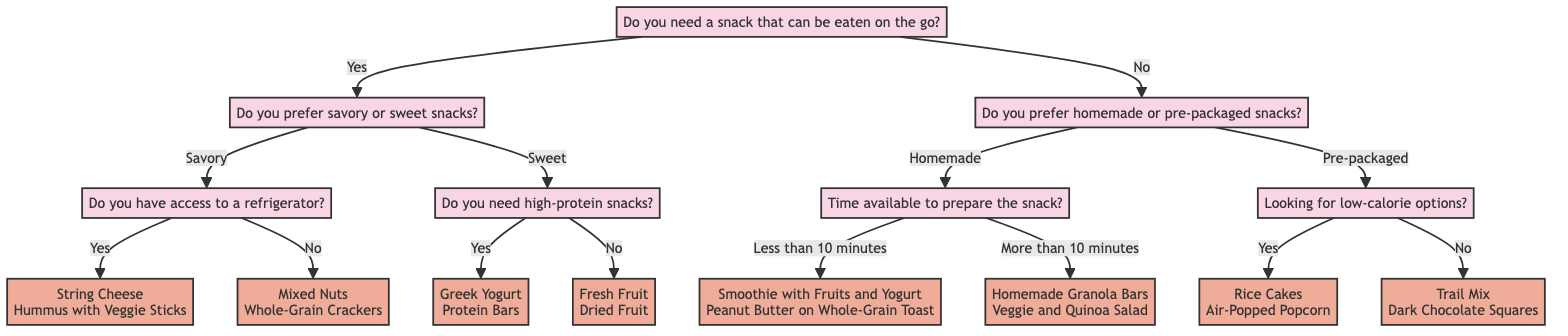What is the first question in the decision tree? The first question in the decision tree is about whether a snack can be eaten on the go. It is posed at the root of the tree and leads to further questions based on the answer.
Answer: Do you need a snack that can be eaten on the go? How many options are available for savory snacks with refrigerator access? When following the path for savory snacks that require a refrigerator, there are two options provided: String Cheese and Hummus with Veggie Sticks. This is derived from the subtree that follows the savory answer under the go question where refrigerator access is affirmed.
Answer: 2 What type of snacks does the tree recommend for someone who prefers homemade snacks and has more than 10 minutes to prepare? Following the path from the decision about preferring homemade snacks, if the user has more than 10 minutes, the options presented are Homemade Granola Bars and Veggie and Quinoa Salad. This follows the logical flow through the diagram to reach these recommendations.
Answer: Homemade Granola Bars, Veggie and Quinoa Salad What snacks are suggested for pre-packaged low-calorie options? If the user prefers pre-packaged snacks and is looking for low-calorie options, they are directed to Rice Cakes and Air-Popped Popcorn. This decision flows through the tree based on the preference for pre-packaged snacks and subsequently seeking lower calorie snacks.
Answer: Rice Cakes, Air-Popped Popcorn If a user answers "No" to having a snack that can be eaten on the go, what is the next question they will encounter? The user who answers "No" to the first question will be asked whether they prefer homemade or pre-packaged snacks. This question follows directly as the next step in the decision-making process in the tree.
Answer: Do you prefer homemade or pre-packaged snacks? What are the two options available if the user prefers sweet snacks and does not need high-protein snacks? If the user prefers sweet snacks and answers that they do not require high-protein, the options presented are Fresh Fruit and Dried Fruit. This is found by tracing the path corresponding to those specific responses in the decision tree.
Answer: Fresh Fruit, Dried Fruit What type of snacks are suggested if the user prefers savory snacks and does not have access to a refrigerator? The path for savory snacks without refrigerator access leads to two options: Mixed Nuts and Whole-Grain Crackers. This is obtained by navigating through the decision tree based on the given answers.
Answer: Mixed Nuts, Whole-Grain Crackers How many types of questions are present in this decision tree? The decision tree contains three types of questions: whether a snack can be eaten on the go, preference for savory or sweet, and preference for homemade or pre-packaged. These categories emerge from the branching structure of the tree.
Answer: 3 